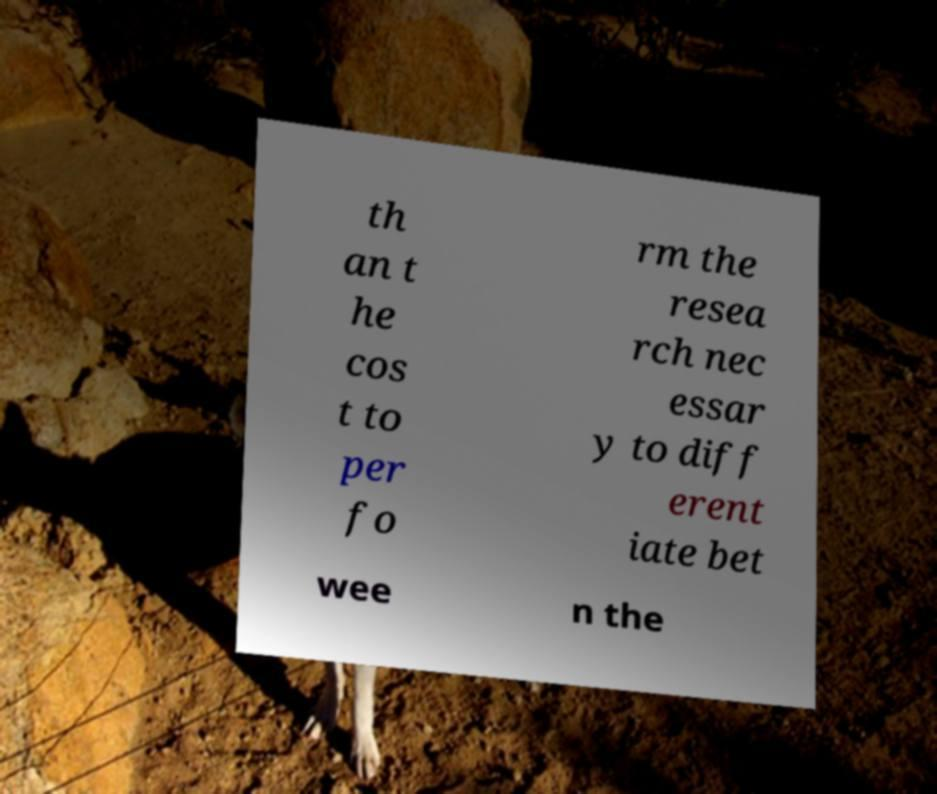For documentation purposes, I need the text within this image transcribed. Could you provide that? th an t he cos t to per fo rm the resea rch nec essar y to diff erent iate bet wee n the 